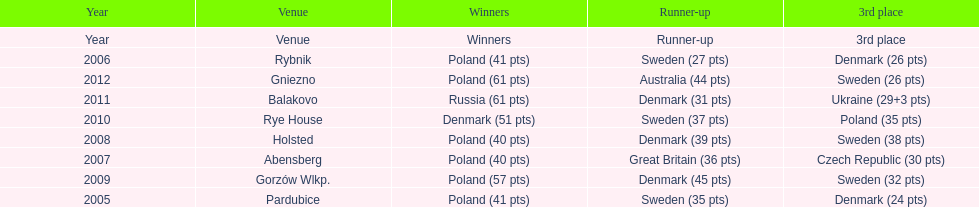After winning first place in 2009, how did poland perform at the speedway junior world championship the subsequent year? 3rd place. 